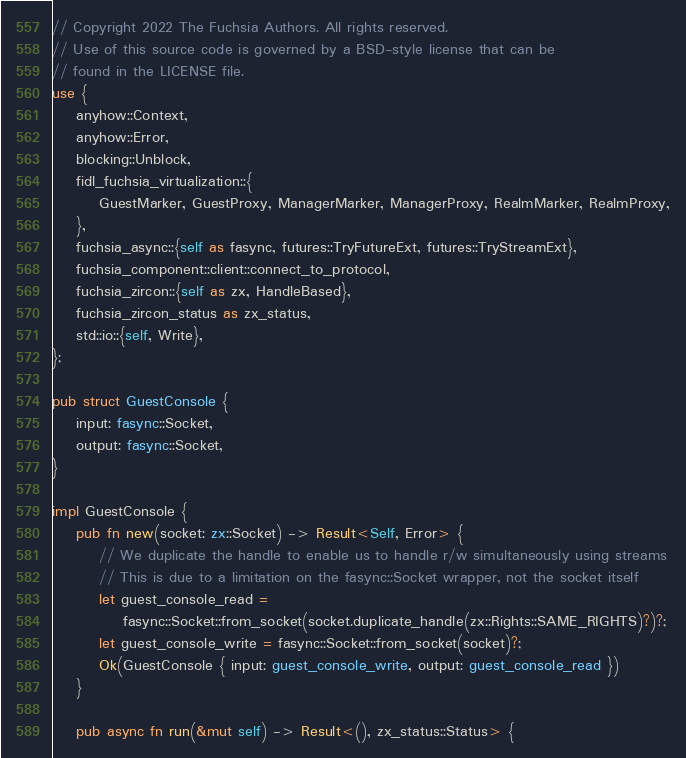Convert code to text. <code><loc_0><loc_0><loc_500><loc_500><_Rust_>// Copyright 2022 The Fuchsia Authors. All rights reserved.
// Use of this source code is governed by a BSD-style license that can be
// found in the LICENSE file.
use {
    anyhow::Context,
    anyhow::Error,
    blocking::Unblock,
    fidl_fuchsia_virtualization::{
        GuestMarker, GuestProxy, ManagerMarker, ManagerProxy, RealmMarker, RealmProxy,
    },
    fuchsia_async::{self as fasync, futures::TryFutureExt, futures::TryStreamExt},
    fuchsia_component::client::connect_to_protocol,
    fuchsia_zircon::{self as zx, HandleBased},
    fuchsia_zircon_status as zx_status,
    std::io::{self, Write},
};

pub struct GuestConsole {
    input: fasync::Socket,
    output: fasync::Socket,
}

impl GuestConsole {
    pub fn new(socket: zx::Socket) -> Result<Self, Error> {
        // We duplicate the handle to enable us to handle r/w simultaneously using streams
        // This is due to a limitation on the fasync::Socket wrapper, not the socket itself
        let guest_console_read =
            fasync::Socket::from_socket(socket.duplicate_handle(zx::Rights::SAME_RIGHTS)?)?;
        let guest_console_write = fasync::Socket::from_socket(socket)?;
        Ok(GuestConsole { input: guest_console_write, output: guest_console_read })
    }

    pub async fn run(&mut self) -> Result<(), zx_status::Status> {</code> 